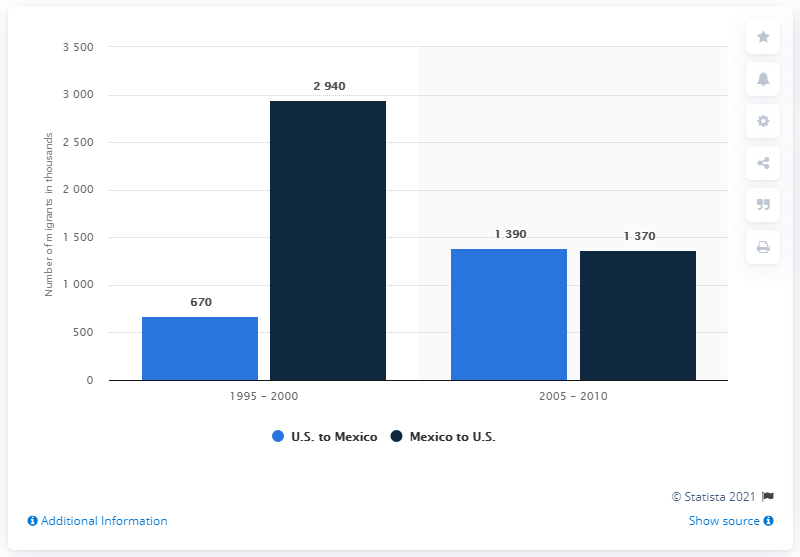List a handful of essential elements in this visual. During the period of 1995 to 2000, an estimated 670 migrants emigrated from the United States to Mexico. During the period of 2005 to 2010, an estimated 1,390 migrants emigrated from the United States to Mexico. 